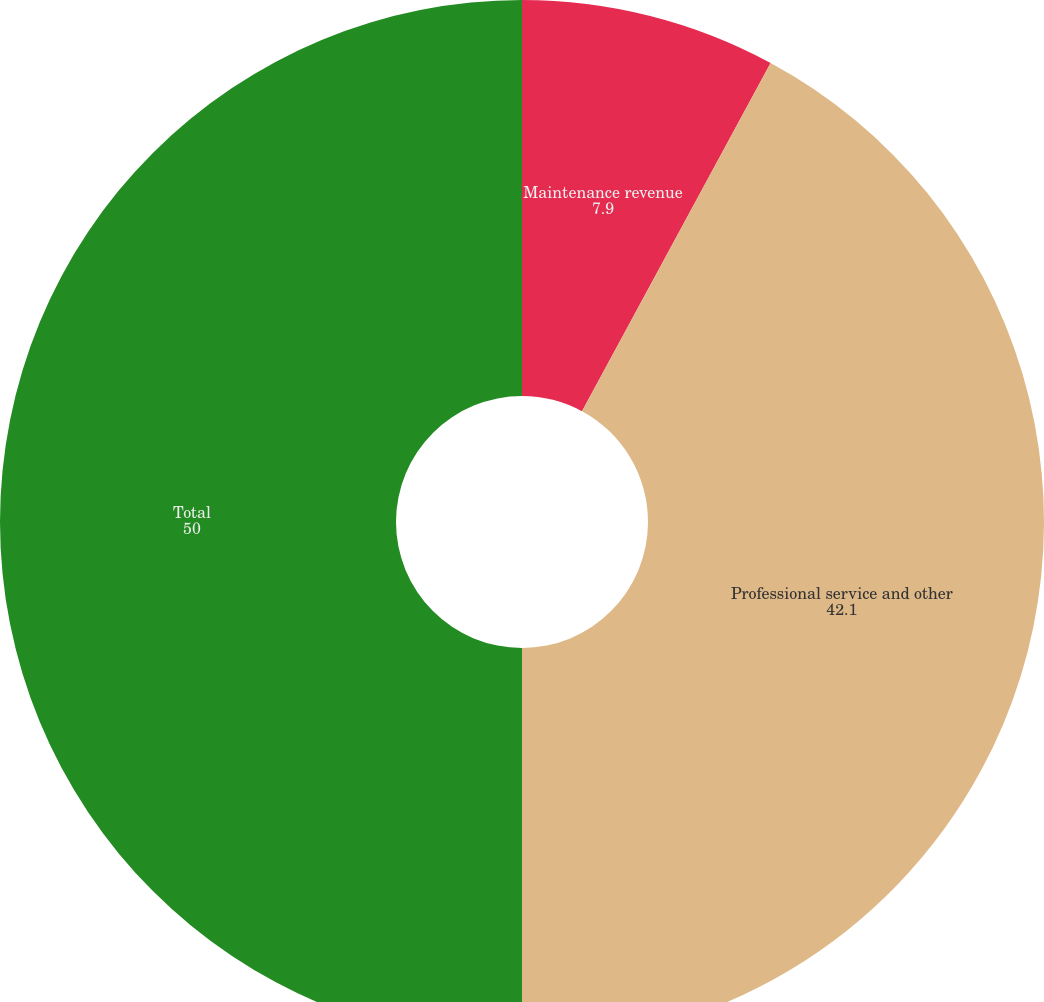Convert chart. <chart><loc_0><loc_0><loc_500><loc_500><pie_chart><fcel>Maintenance revenue<fcel>Professional service and other<fcel>Total<nl><fcel>7.9%<fcel>42.1%<fcel>50.0%<nl></chart> 